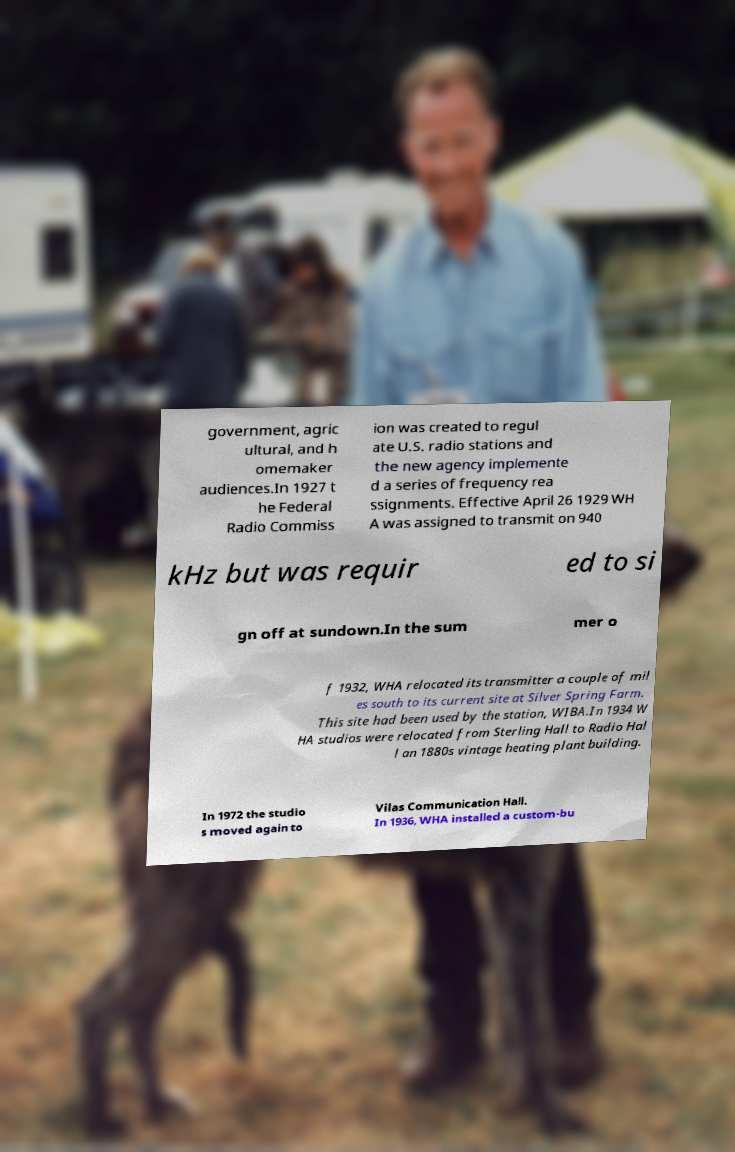Please read and relay the text visible in this image. What does it say? government, agric ultural, and h omemaker audiences.In 1927 t he Federal Radio Commiss ion was created to regul ate U.S. radio stations and the new agency implemente d a series of frequency rea ssignments. Effective April 26 1929 WH A was assigned to transmit on 940 kHz but was requir ed to si gn off at sundown.In the sum mer o f 1932, WHA relocated its transmitter a couple of mil es south to its current site at Silver Spring Farm. This site had been used by the station, WIBA.In 1934 W HA studios were relocated from Sterling Hall to Radio Hal l an 1880s vintage heating plant building. In 1972 the studio s moved again to Vilas Communication Hall. In 1936, WHA installed a custom-bu 